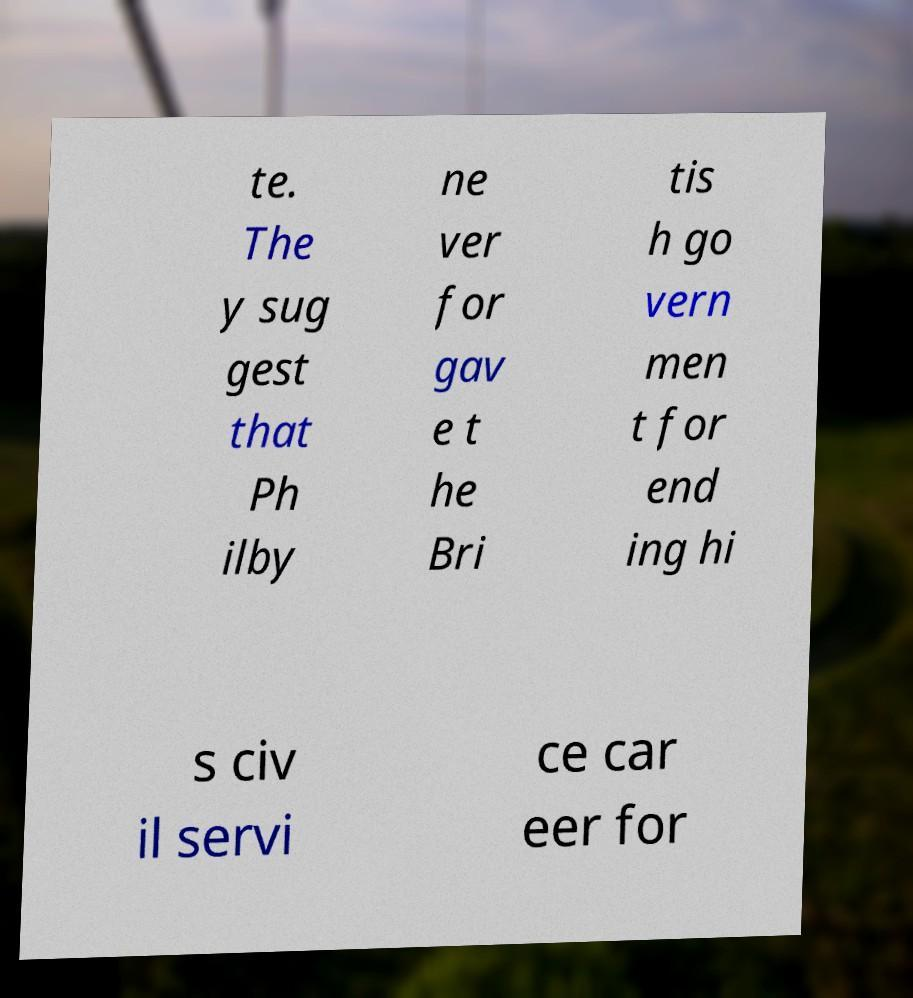Please read and relay the text visible in this image. What does it say? te. The y sug gest that Ph ilby ne ver for gav e t he Bri tis h go vern men t for end ing hi s civ il servi ce car eer for 